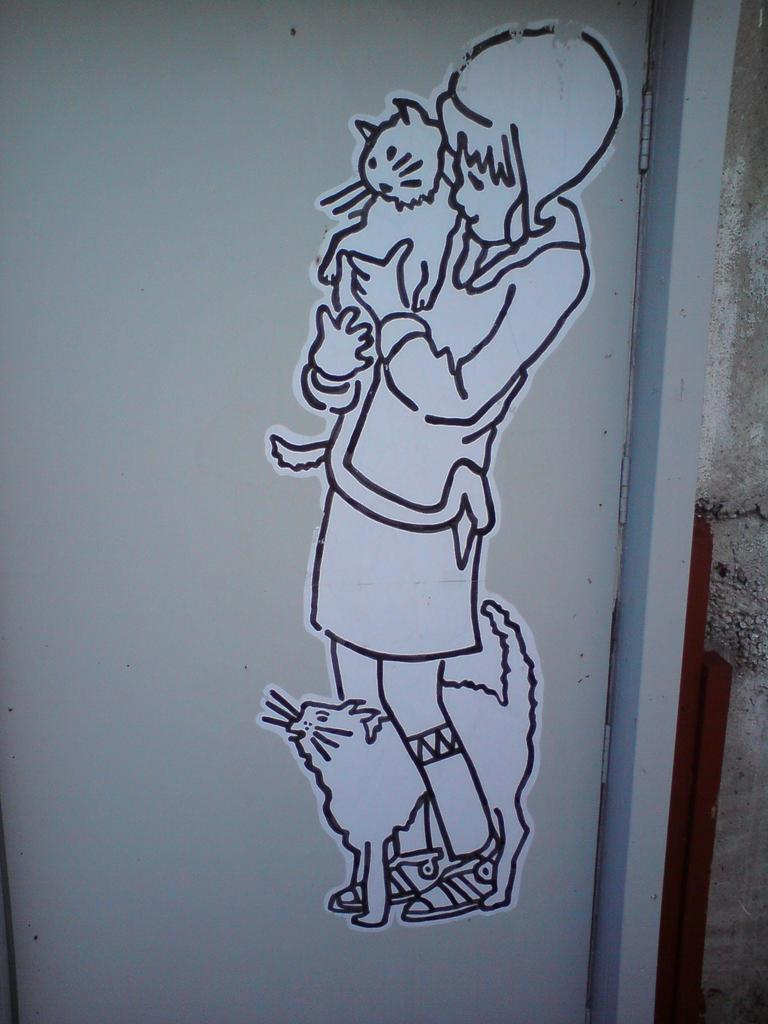What type of structure can be seen in the image? There is a wall in the image. Is there any entrance visible in the image? Yes, there is a door in the image. What is depicted on the door? There is a drawing of a girl on the door. Are there any animals in the drawing on the door? Yes, there are two cats in the drawing on the door. What is the mass of the girl in the drawing? There is no information about the mass of the girl in the drawing. --- Facts: 1. There is a car in the image. 2. The car is red. 3. The car has four wheels. 4. There is a person standing next to the car. 5. The person is holding a phone. Absurd Topics: elephant, piano Conversation: What is the main subject in the image? There is a car in the image. What color is the car? The car is red. How many wheels does the car have? The car has four wheels. Is there a person in the image? Yes, there is a person standing next to the car. What is the person holding? The person is holding a phone. Reasoning: Let's think step by step in order to produce the conversation. We start by identifying the main subject of the image, which is the car. Next, we describe specific features of the car, such as its color and the number of wheels it has. Then, we observe the actions of the person in the image, noting that they are holding a phone. Finally, we ensure that the language is simple and clear. Absurd Question/Answer: Can you hear the elephant playing the piano in the image? There is no elephant or piano present in the image. 